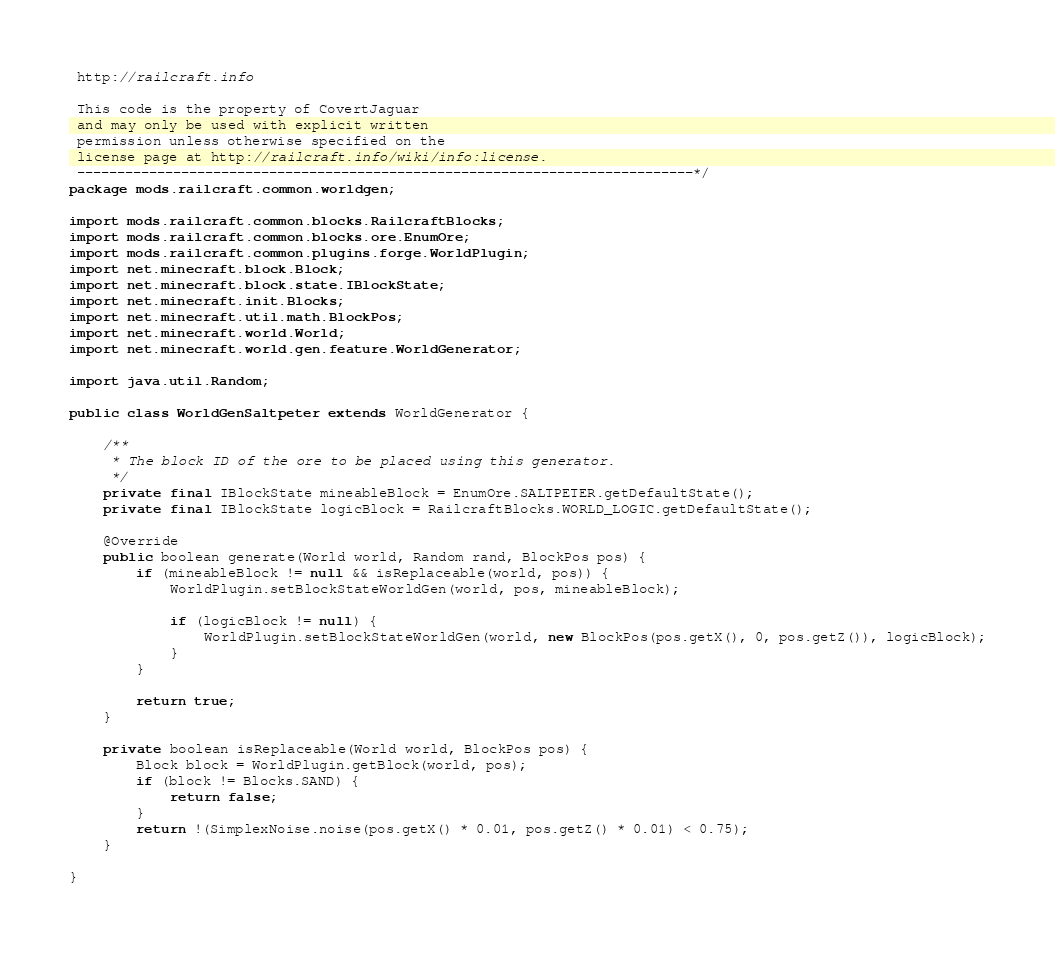<code> <loc_0><loc_0><loc_500><loc_500><_Java_> http://railcraft.info

 This code is the property of CovertJaguar
 and may only be used with explicit written
 permission unless otherwise specified on the
 license page at http://railcraft.info/wiki/info:license.
 -----------------------------------------------------------------------------*/
package mods.railcraft.common.worldgen;

import mods.railcraft.common.blocks.RailcraftBlocks;
import mods.railcraft.common.blocks.ore.EnumOre;
import mods.railcraft.common.plugins.forge.WorldPlugin;
import net.minecraft.block.Block;
import net.minecraft.block.state.IBlockState;
import net.minecraft.init.Blocks;
import net.minecraft.util.math.BlockPos;
import net.minecraft.world.World;
import net.minecraft.world.gen.feature.WorldGenerator;

import java.util.Random;

public class WorldGenSaltpeter extends WorldGenerator {

    /**
     * The block ID of the ore to be placed using this generator.
     */
    private final IBlockState mineableBlock = EnumOre.SALTPETER.getDefaultState();
    private final IBlockState logicBlock = RailcraftBlocks.WORLD_LOGIC.getDefaultState();

    @Override
    public boolean generate(World world, Random rand, BlockPos pos) {
        if (mineableBlock != null && isReplaceable(world, pos)) {
            WorldPlugin.setBlockStateWorldGen(world, pos, mineableBlock);

            if (logicBlock != null) {
                WorldPlugin.setBlockStateWorldGen(world, new BlockPos(pos.getX(), 0, pos.getZ()), logicBlock);
            }
        }

        return true;
    }

    private boolean isReplaceable(World world, BlockPos pos) {
        Block block = WorldPlugin.getBlock(world, pos);
        if (block != Blocks.SAND) {
            return false;
        }
        return !(SimplexNoise.noise(pos.getX() * 0.01, pos.getZ() * 0.01) < 0.75);
    }

}
</code> 